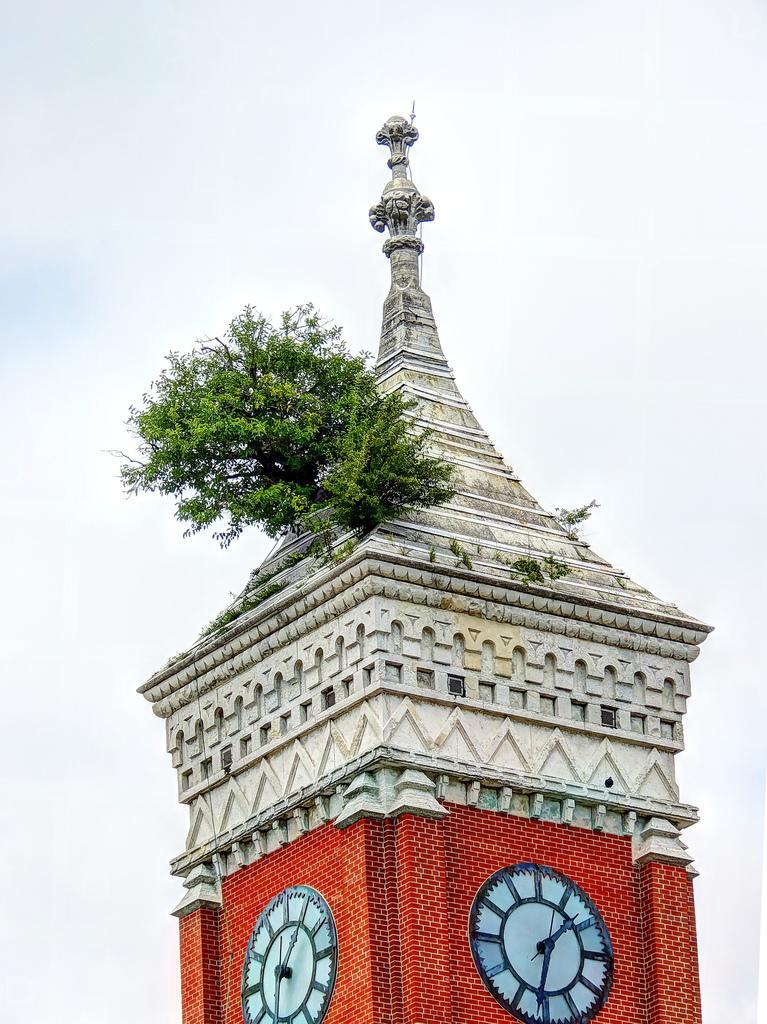Can you describe this image briefly? In this image we can see a clock tower with a plant. In the background of the image there is sky. 